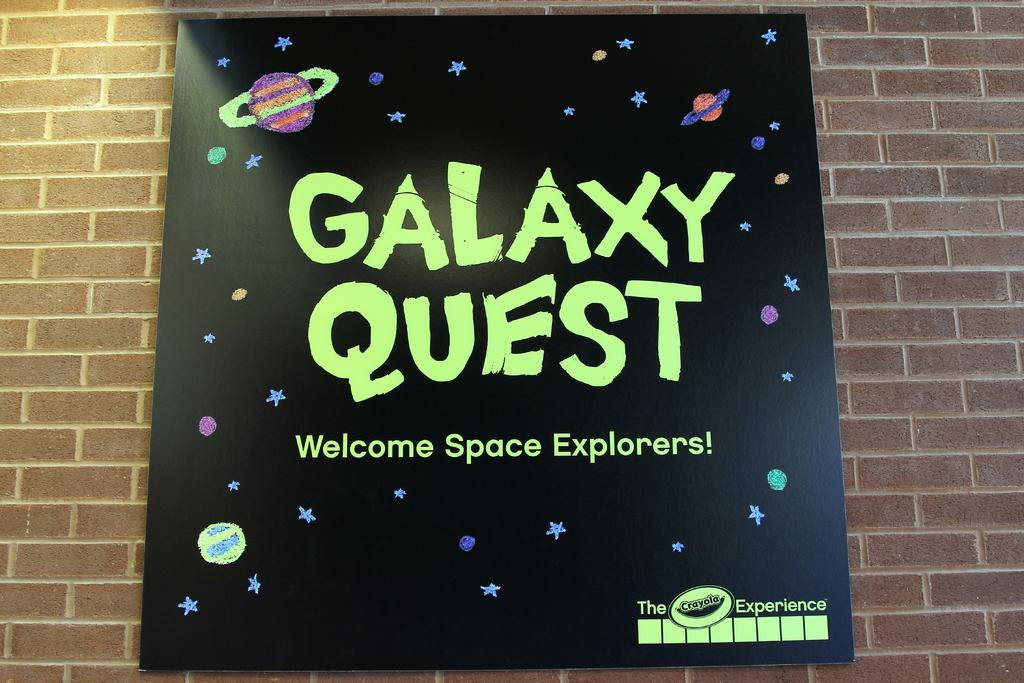<image>
Present a compact description of the photo's key features. A sign advertising Galaxy Quest in black with green letters. 